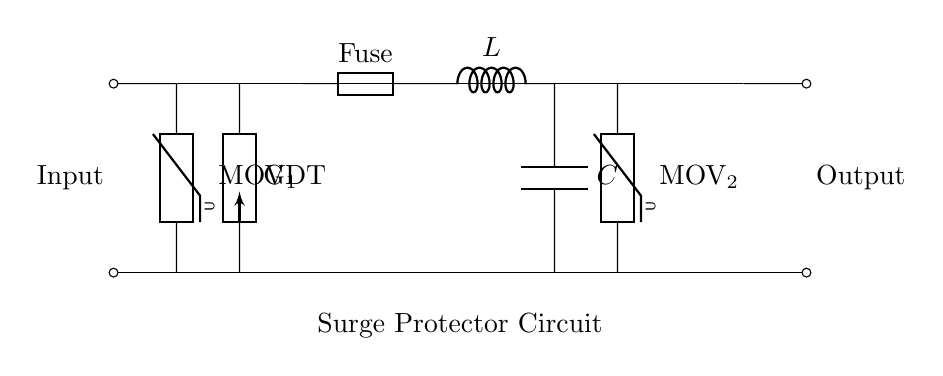What are the components in this circuit? The main components in the circuit are the main power line, two Metal Oxide Varistors, a Gas Discharge Tube, a Fuse, an Inductor, and a Capacitor, which are all visible in the diagram.
Answer: main power line, MOV 1, MOV 2, GDT, Fuse, L, C What does MOV stand for? MOV stands for Metal Oxide Varistor, which is a component used to protect against voltage spikes in the circuit.
Answer: Metal Oxide Varistor How many varistors are present in the circuit? There are two varistors in the circuit, labeled as MOV 1 and MOV 2.
Answer: 2 What is the role of the Fuse in this circuit? The Fuse serves as a protective device that interrupts the current flow if the current exceeds a certain limit, preventing damage to the other components.
Answer: Interrupt current flow What is the purpose of the Gas Discharge Tube? The Gas Discharge Tube acts as a surge protective device that helps to divert excess voltage away from sensitive components in the circuit.
Answer: Divert excess voltage What happens to the current flow when the Fuse blows? When the Fuse blows, it breaks the circuit, interrupting the current flow and protecting the components downstream from damage due to excess current.
Answer: Interrupts current flow What type of circuit is this? This is a surge protector circuit designed to safeguard household electronics and appliances from voltage spikes.
Answer: Surge protector circuit 